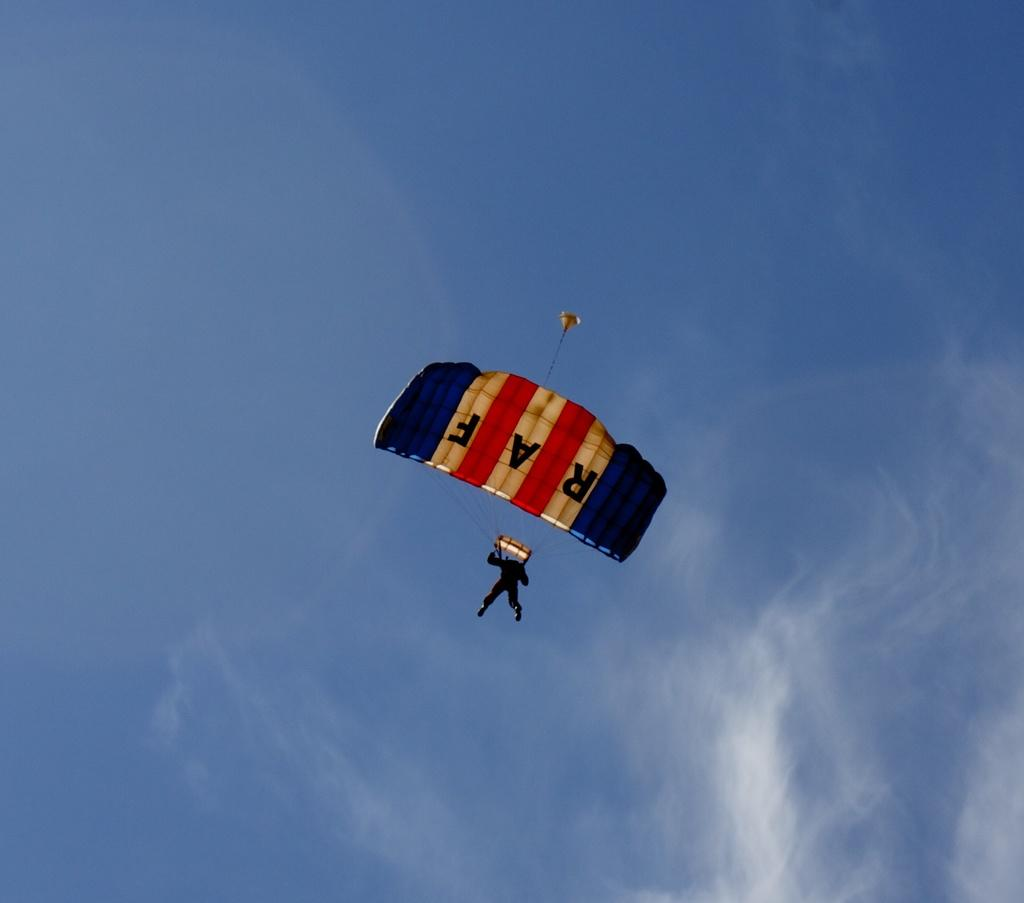<image>
Present a compact description of the photo's key features. A person parachuting by himself with RAF on the parachute. 